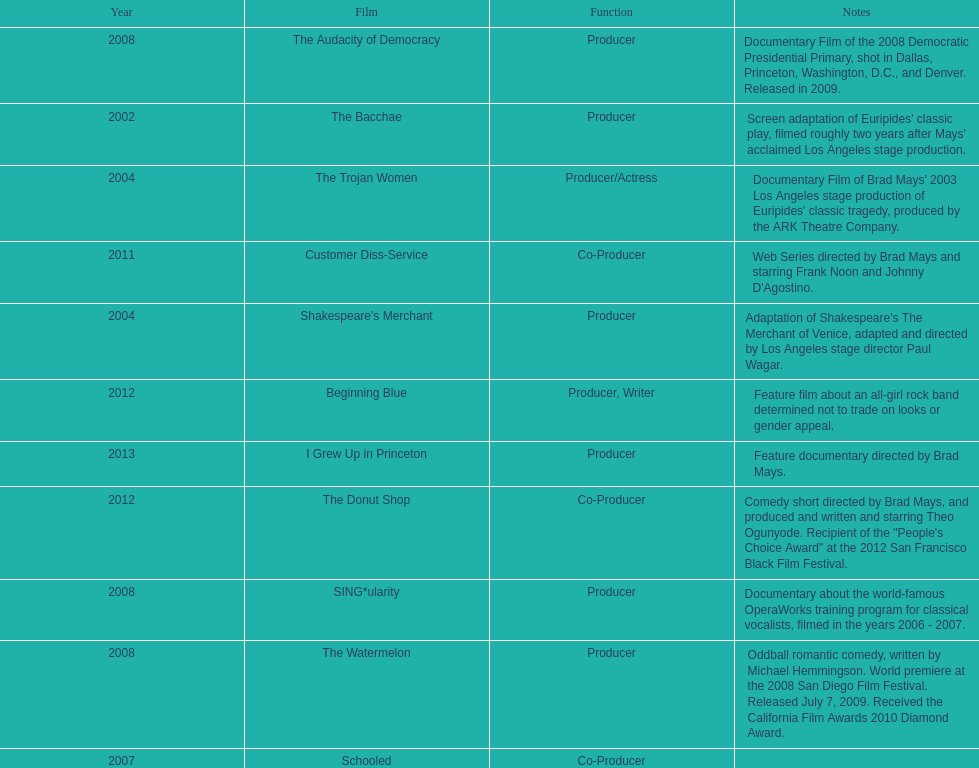Which year was there at least three movies? 2008. 